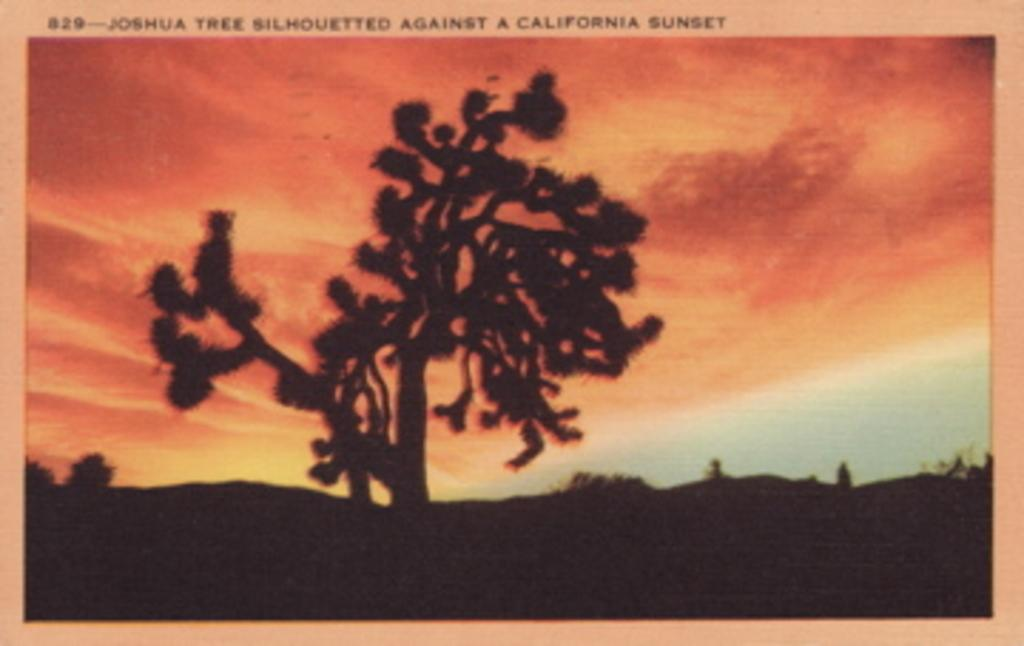What type of visual is the image? The image is a poster. What can be seen on the poster besides text? There are pictures on the poster. What information is provided on the poster through text? There is text on the poster. What type of trail can be seen on the poster? There is no trail present on the poster; it features pictures and text. What type of secretary is depicted in the poster? There is no secretary depicted in the poster; it is a poster with pictures and text. 